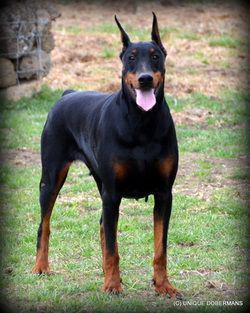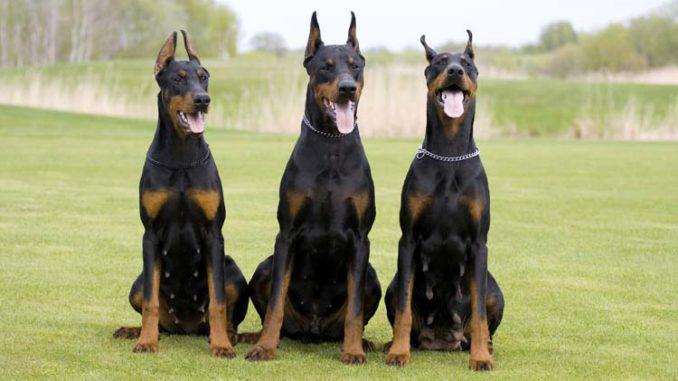The first image is the image on the left, the second image is the image on the right. Evaluate the accuracy of this statement regarding the images: "There are four dogs.". Is it true? Answer yes or no. Yes. The first image is the image on the left, the second image is the image on the right. For the images shown, is this caption "Three dogs are sitting in the grass in one of the images." true? Answer yes or no. Yes. 